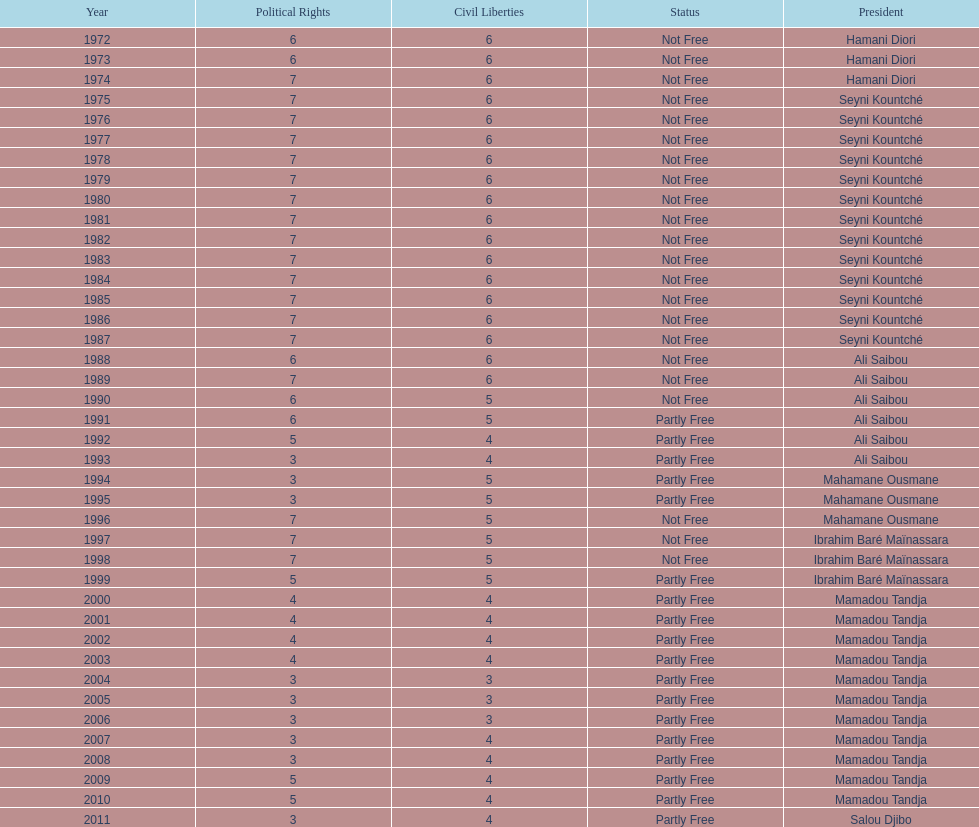Who became president after hamani diori in 1974? Seyni Kountché. 